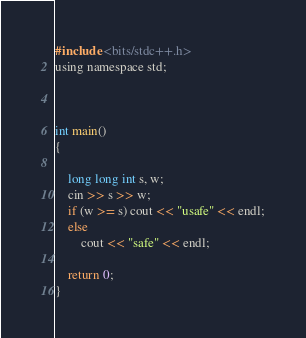<code> <loc_0><loc_0><loc_500><loc_500><_C_>#include <bits/stdc++.h>
using namespace std;



int main()
{

	long long int s, w;
	cin >> s >> w;
	if (w >= s) cout << "usafe" << endl;
	else
		cout << "safe" << endl;

	return 0;
}
</code> 